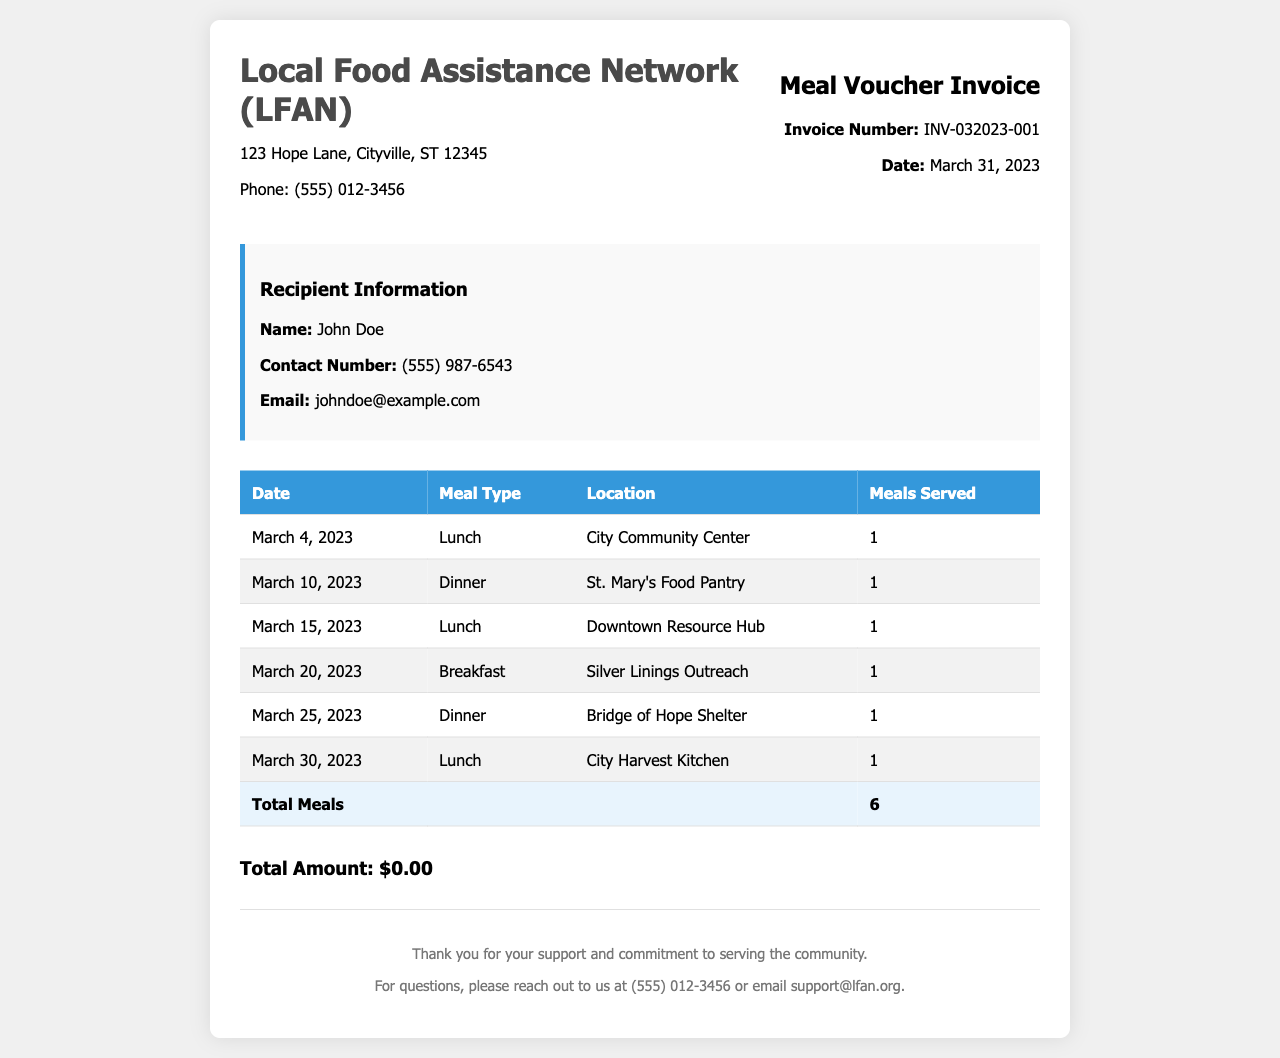What is the name of the charity? The document states that the charity is Local Food Assistance Network (LFAN).
Answer: Local Food Assistance Network (LFAN) What is the invoice number? The invoice number is explicitly provided in the document as INV-032023-001.
Answer: INV-032023-001 How many meals were served in total? The total number of meals is summarized at the end of the table as 6.
Answer: 6 What date was the invoice issued? The date is mentioned in the invoice details as March 31, 2023.
Answer: March 31, 2023 Where was the March 10 meal served? The location for the meal on March 10 is stated as St. Mary's Food Pantry.
Answer: St. Mary's Food Pantry What meal type was served on March 20? The meal type for March 20 is listed as Breakfast in the table.
Answer: Breakfast How many meals were served at the City Community Center? The table indicates that 1 meal was served at the City Community Center on March 4.
Answer: 1 What is the contact number for the charity? The contact number for the charity is provided as (555) 012-3456.
Answer: (555) 012-3456 What type of meal was served on March 30? The type of meal served on March 30 is recorded as Lunch in the document.
Answer: Lunch 